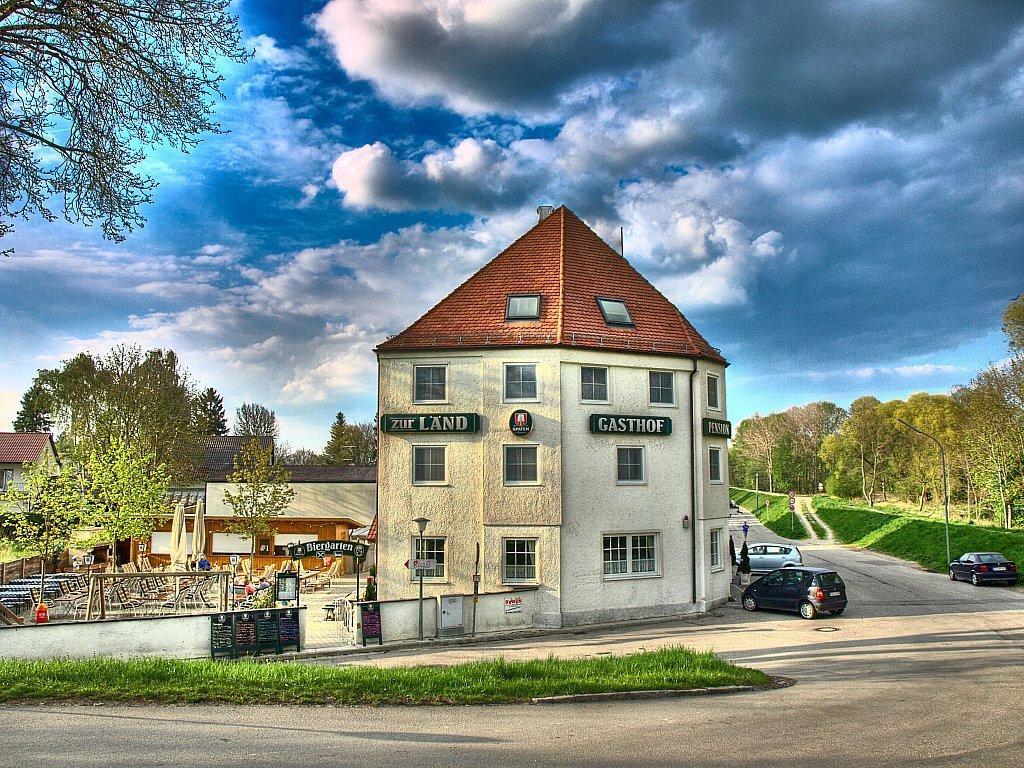Describe this image in one or two sentences. There are few cars on the road. There are few street lights on the grass land, behind there are few trees. There are few houses, before there are few trees and benches. There is some grassland in between the road. Behind houses there are few trees. Top of image there is sky with some clouds. Left top there is a tree. 